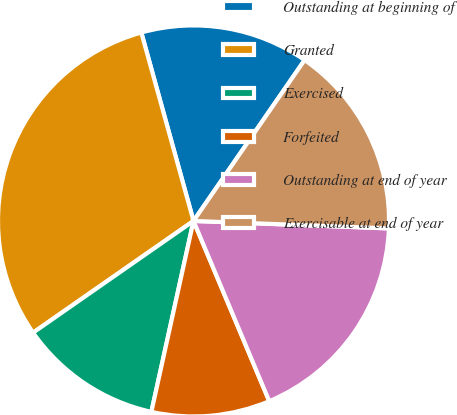<chart> <loc_0><loc_0><loc_500><loc_500><pie_chart><fcel>Outstanding at beginning of<fcel>Granted<fcel>Exercised<fcel>Forfeited<fcel>Outstanding at end of year<fcel>Exercisable at end of year<nl><fcel>13.92%<fcel>30.38%<fcel>11.86%<fcel>9.79%<fcel>18.06%<fcel>15.99%<nl></chart> 